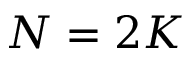Convert formula to latex. <formula><loc_0><loc_0><loc_500><loc_500>N = 2 K</formula> 